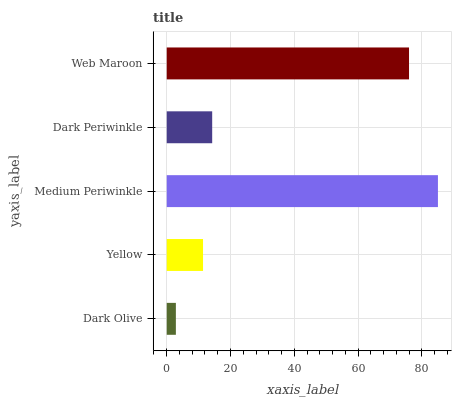Is Dark Olive the minimum?
Answer yes or no. Yes. Is Medium Periwinkle the maximum?
Answer yes or no. Yes. Is Yellow the minimum?
Answer yes or no. No. Is Yellow the maximum?
Answer yes or no. No. Is Yellow greater than Dark Olive?
Answer yes or no. Yes. Is Dark Olive less than Yellow?
Answer yes or no. Yes. Is Dark Olive greater than Yellow?
Answer yes or no. No. Is Yellow less than Dark Olive?
Answer yes or no. No. Is Dark Periwinkle the high median?
Answer yes or no. Yes. Is Dark Periwinkle the low median?
Answer yes or no. Yes. Is Dark Olive the high median?
Answer yes or no. No. Is Web Maroon the low median?
Answer yes or no. No. 